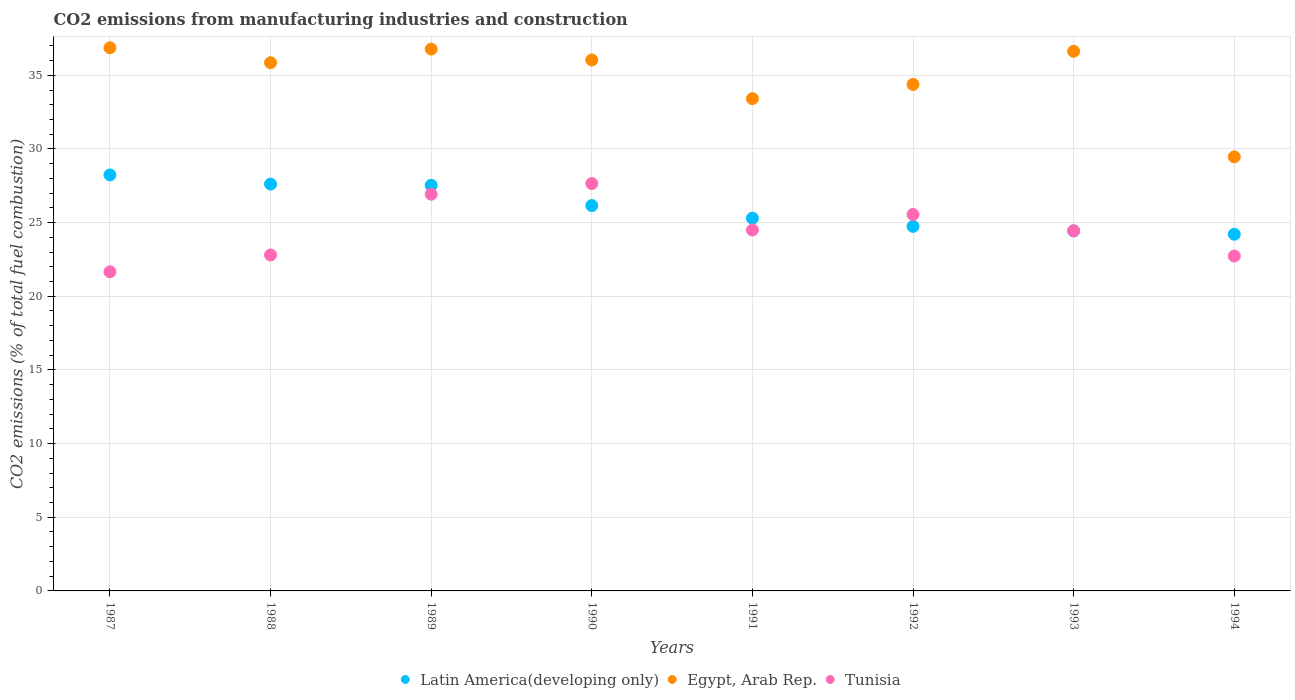How many different coloured dotlines are there?
Keep it short and to the point. 3. What is the amount of CO2 emitted in Tunisia in 1989?
Offer a terse response. 26.93. Across all years, what is the maximum amount of CO2 emitted in Tunisia?
Offer a terse response. 27.65. Across all years, what is the minimum amount of CO2 emitted in Latin America(developing only)?
Keep it short and to the point. 24.21. In which year was the amount of CO2 emitted in Egypt, Arab Rep. maximum?
Offer a terse response. 1987. What is the total amount of CO2 emitted in Tunisia in the graph?
Your answer should be very brief. 196.26. What is the difference between the amount of CO2 emitted in Egypt, Arab Rep. in 1993 and that in 1994?
Offer a very short reply. 7.17. What is the difference between the amount of CO2 emitted in Tunisia in 1991 and the amount of CO2 emitted in Egypt, Arab Rep. in 1990?
Your answer should be compact. -11.54. What is the average amount of CO2 emitted in Egypt, Arab Rep. per year?
Provide a succinct answer. 34.93. In the year 1991, what is the difference between the amount of CO2 emitted in Latin America(developing only) and amount of CO2 emitted in Tunisia?
Make the answer very short. 0.8. What is the ratio of the amount of CO2 emitted in Egypt, Arab Rep. in 1987 to that in 1990?
Give a very brief answer. 1.02. Is the difference between the amount of CO2 emitted in Latin America(developing only) in 1988 and 1993 greater than the difference between the amount of CO2 emitted in Tunisia in 1988 and 1993?
Keep it short and to the point. Yes. What is the difference between the highest and the second highest amount of CO2 emitted in Egypt, Arab Rep.?
Make the answer very short. 0.09. What is the difference between the highest and the lowest amount of CO2 emitted in Egypt, Arab Rep.?
Make the answer very short. 7.4. In how many years, is the amount of CO2 emitted in Tunisia greater than the average amount of CO2 emitted in Tunisia taken over all years?
Offer a very short reply. 3. Is the sum of the amount of CO2 emitted in Egypt, Arab Rep. in 1989 and 1992 greater than the maximum amount of CO2 emitted in Tunisia across all years?
Offer a very short reply. Yes. Does the amount of CO2 emitted in Latin America(developing only) monotonically increase over the years?
Offer a terse response. No. Is the amount of CO2 emitted in Latin America(developing only) strictly less than the amount of CO2 emitted in Egypt, Arab Rep. over the years?
Your answer should be compact. Yes. How are the legend labels stacked?
Offer a terse response. Horizontal. What is the title of the graph?
Give a very brief answer. CO2 emissions from manufacturing industries and construction. Does "Uzbekistan" appear as one of the legend labels in the graph?
Make the answer very short. No. What is the label or title of the X-axis?
Give a very brief answer. Years. What is the label or title of the Y-axis?
Your answer should be compact. CO2 emissions (% of total fuel combustion). What is the CO2 emissions (% of total fuel combustion) in Latin America(developing only) in 1987?
Offer a very short reply. 28.24. What is the CO2 emissions (% of total fuel combustion) in Egypt, Arab Rep. in 1987?
Your answer should be very brief. 36.87. What is the CO2 emissions (% of total fuel combustion) in Tunisia in 1987?
Provide a short and direct response. 21.66. What is the CO2 emissions (% of total fuel combustion) in Latin America(developing only) in 1988?
Your answer should be very brief. 27.61. What is the CO2 emissions (% of total fuel combustion) of Egypt, Arab Rep. in 1988?
Provide a succinct answer. 35.85. What is the CO2 emissions (% of total fuel combustion) of Tunisia in 1988?
Offer a terse response. 22.8. What is the CO2 emissions (% of total fuel combustion) in Latin America(developing only) in 1989?
Provide a short and direct response. 27.53. What is the CO2 emissions (% of total fuel combustion) in Egypt, Arab Rep. in 1989?
Your answer should be very brief. 36.78. What is the CO2 emissions (% of total fuel combustion) of Tunisia in 1989?
Provide a succinct answer. 26.93. What is the CO2 emissions (% of total fuel combustion) of Latin America(developing only) in 1990?
Ensure brevity in your answer.  26.15. What is the CO2 emissions (% of total fuel combustion) of Egypt, Arab Rep. in 1990?
Your response must be concise. 36.04. What is the CO2 emissions (% of total fuel combustion) of Tunisia in 1990?
Provide a succinct answer. 27.65. What is the CO2 emissions (% of total fuel combustion) of Latin America(developing only) in 1991?
Your response must be concise. 25.3. What is the CO2 emissions (% of total fuel combustion) of Egypt, Arab Rep. in 1991?
Offer a terse response. 33.41. What is the CO2 emissions (% of total fuel combustion) of Tunisia in 1991?
Offer a very short reply. 24.5. What is the CO2 emissions (% of total fuel combustion) of Latin America(developing only) in 1992?
Offer a very short reply. 24.74. What is the CO2 emissions (% of total fuel combustion) of Egypt, Arab Rep. in 1992?
Give a very brief answer. 34.38. What is the CO2 emissions (% of total fuel combustion) of Tunisia in 1992?
Give a very brief answer. 25.55. What is the CO2 emissions (% of total fuel combustion) in Latin America(developing only) in 1993?
Your response must be concise. 24.44. What is the CO2 emissions (% of total fuel combustion) of Egypt, Arab Rep. in 1993?
Your response must be concise. 36.63. What is the CO2 emissions (% of total fuel combustion) of Tunisia in 1993?
Your answer should be very brief. 24.44. What is the CO2 emissions (% of total fuel combustion) in Latin America(developing only) in 1994?
Your answer should be very brief. 24.21. What is the CO2 emissions (% of total fuel combustion) of Egypt, Arab Rep. in 1994?
Provide a succinct answer. 29.46. What is the CO2 emissions (% of total fuel combustion) of Tunisia in 1994?
Ensure brevity in your answer.  22.73. Across all years, what is the maximum CO2 emissions (% of total fuel combustion) of Latin America(developing only)?
Your response must be concise. 28.24. Across all years, what is the maximum CO2 emissions (% of total fuel combustion) in Egypt, Arab Rep.?
Ensure brevity in your answer.  36.87. Across all years, what is the maximum CO2 emissions (% of total fuel combustion) of Tunisia?
Your answer should be compact. 27.65. Across all years, what is the minimum CO2 emissions (% of total fuel combustion) of Latin America(developing only)?
Your answer should be compact. 24.21. Across all years, what is the minimum CO2 emissions (% of total fuel combustion) in Egypt, Arab Rep.?
Your answer should be very brief. 29.46. Across all years, what is the minimum CO2 emissions (% of total fuel combustion) of Tunisia?
Your response must be concise. 21.66. What is the total CO2 emissions (% of total fuel combustion) of Latin America(developing only) in the graph?
Your answer should be compact. 208.22. What is the total CO2 emissions (% of total fuel combustion) of Egypt, Arab Rep. in the graph?
Offer a very short reply. 279.41. What is the total CO2 emissions (% of total fuel combustion) in Tunisia in the graph?
Your answer should be compact. 196.26. What is the difference between the CO2 emissions (% of total fuel combustion) of Latin America(developing only) in 1987 and that in 1988?
Keep it short and to the point. 0.62. What is the difference between the CO2 emissions (% of total fuel combustion) in Tunisia in 1987 and that in 1988?
Your answer should be very brief. -1.14. What is the difference between the CO2 emissions (% of total fuel combustion) of Latin America(developing only) in 1987 and that in 1989?
Your answer should be compact. 0.71. What is the difference between the CO2 emissions (% of total fuel combustion) in Egypt, Arab Rep. in 1987 and that in 1989?
Offer a very short reply. 0.09. What is the difference between the CO2 emissions (% of total fuel combustion) in Tunisia in 1987 and that in 1989?
Make the answer very short. -5.27. What is the difference between the CO2 emissions (% of total fuel combustion) of Latin America(developing only) in 1987 and that in 1990?
Keep it short and to the point. 2.08. What is the difference between the CO2 emissions (% of total fuel combustion) of Egypt, Arab Rep. in 1987 and that in 1990?
Offer a terse response. 0.83. What is the difference between the CO2 emissions (% of total fuel combustion) in Tunisia in 1987 and that in 1990?
Provide a short and direct response. -5.99. What is the difference between the CO2 emissions (% of total fuel combustion) in Latin America(developing only) in 1987 and that in 1991?
Your answer should be compact. 2.94. What is the difference between the CO2 emissions (% of total fuel combustion) of Egypt, Arab Rep. in 1987 and that in 1991?
Keep it short and to the point. 3.45. What is the difference between the CO2 emissions (% of total fuel combustion) of Tunisia in 1987 and that in 1991?
Make the answer very short. -2.84. What is the difference between the CO2 emissions (% of total fuel combustion) in Latin America(developing only) in 1987 and that in 1992?
Make the answer very short. 3.49. What is the difference between the CO2 emissions (% of total fuel combustion) in Egypt, Arab Rep. in 1987 and that in 1992?
Give a very brief answer. 2.49. What is the difference between the CO2 emissions (% of total fuel combustion) of Tunisia in 1987 and that in 1992?
Keep it short and to the point. -3.89. What is the difference between the CO2 emissions (% of total fuel combustion) of Latin America(developing only) in 1987 and that in 1993?
Your response must be concise. 3.8. What is the difference between the CO2 emissions (% of total fuel combustion) in Egypt, Arab Rep. in 1987 and that in 1993?
Your response must be concise. 0.24. What is the difference between the CO2 emissions (% of total fuel combustion) in Tunisia in 1987 and that in 1993?
Your answer should be compact. -2.78. What is the difference between the CO2 emissions (% of total fuel combustion) of Latin America(developing only) in 1987 and that in 1994?
Offer a very short reply. 4.03. What is the difference between the CO2 emissions (% of total fuel combustion) of Egypt, Arab Rep. in 1987 and that in 1994?
Offer a very short reply. 7.4. What is the difference between the CO2 emissions (% of total fuel combustion) of Tunisia in 1987 and that in 1994?
Give a very brief answer. -1.07. What is the difference between the CO2 emissions (% of total fuel combustion) in Latin America(developing only) in 1988 and that in 1989?
Offer a very short reply. 0.09. What is the difference between the CO2 emissions (% of total fuel combustion) of Egypt, Arab Rep. in 1988 and that in 1989?
Your answer should be compact. -0.93. What is the difference between the CO2 emissions (% of total fuel combustion) of Tunisia in 1988 and that in 1989?
Give a very brief answer. -4.12. What is the difference between the CO2 emissions (% of total fuel combustion) in Latin America(developing only) in 1988 and that in 1990?
Make the answer very short. 1.46. What is the difference between the CO2 emissions (% of total fuel combustion) of Egypt, Arab Rep. in 1988 and that in 1990?
Your response must be concise. -0.19. What is the difference between the CO2 emissions (% of total fuel combustion) of Tunisia in 1988 and that in 1990?
Provide a succinct answer. -4.85. What is the difference between the CO2 emissions (% of total fuel combustion) in Latin America(developing only) in 1988 and that in 1991?
Offer a very short reply. 2.32. What is the difference between the CO2 emissions (% of total fuel combustion) of Egypt, Arab Rep. in 1988 and that in 1991?
Your answer should be very brief. 2.44. What is the difference between the CO2 emissions (% of total fuel combustion) in Tunisia in 1988 and that in 1991?
Your answer should be compact. -1.69. What is the difference between the CO2 emissions (% of total fuel combustion) of Latin America(developing only) in 1988 and that in 1992?
Provide a short and direct response. 2.87. What is the difference between the CO2 emissions (% of total fuel combustion) of Egypt, Arab Rep. in 1988 and that in 1992?
Keep it short and to the point. 1.47. What is the difference between the CO2 emissions (% of total fuel combustion) in Tunisia in 1988 and that in 1992?
Provide a succinct answer. -2.75. What is the difference between the CO2 emissions (% of total fuel combustion) of Latin America(developing only) in 1988 and that in 1993?
Offer a terse response. 3.18. What is the difference between the CO2 emissions (% of total fuel combustion) in Egypt, Arab Rep. in 1988 and that in 1993?
Make the answer very short. -0.78. What is the difference between the CO2 emissions (% of total fuel combustion) of Tunisia in 1988 and that in 1993?
Offer a terse response. -1.64. What is the difference between the CO2 emissions (% of total fuel combustion) of Latin America(developing only) in 1988 and that in 1994?
Provide a short and direct response. 3.4. What is the difference between the CO2 emissions (% of total fuel combustion) in Egypt, Arab Rep. in 1988 and that in 1994?
Your answer should be very brief. 6.39. What is the difference between the CO2 emissions (% of total fuel combustion) of Tunisia in 1988 and that in 1994?
Give a very brief answer. 0.07. What is the difference between the CO2 emissions (% of total fuel combustion) of Latin America(developing only) in 1989 and that in 1990?
Provide a short and direct response. 1.37. What is the difference between the CO2 emissions (% of total fuel combustion) in Egypt, Arab Rep. in 1989 and that in 1990?
Your response must be concise. 0.74. What is the difference between the CO2 emissions (% of total fuel combustion) of Tunisia in 1989 and that in 1990?
Your response must be concise. -0.72. What is the difference between the CO2 emissions (% of total fuel combustion) of Latin America(developing only) in 1989 and that in 1991?
Give a very brief answer. 2.23. What is the difference between the CO2 emissions (% of total fuel combustion) in Egypt, Arab Rep. in 1989 and that in 1991?
Offer a very short reply. 3.36. What is the difference between the CO2 emissions (% of total fuel combustion) in Tunisia in 1989 and that in 1991?
Provide a short and direct response. 2.43. What is the difference between the CO2 emissions (% of total fuel combustion) of Latin America(developing only) in 1989 and that in 1992?
Your answer should be compact. 2.78. What is the difference between the CO2 emissions (% of total fuel combustion) in Egypt, Arab Rep. in 1989 and that in 1992?
Keep it short and to the point. 2.4. What is the difference between the CO2 emissions (% of total fuel combustion) in Tunisia in 1989 and that in 1992?
Offer a terse response. 1.38. What is the difference between the CO2 emissions (% of total fuel combustion) of Latin America(developing only) in 1989 and that in 1993?
Your answer should be compact. 3.09. What is the difference between the CO2 emissions (% of total fuel combustion) in Egypt, Arab Rep. in 1989 and that in 1993?
Offer a very short reply. 0.15. What is the difference between the CO2 emissions (% of total fuel combustion) in Tunisia in 1989 and that in 1993?
Offer a terse response. 2.48. What is the difference between the CO2 emissions (% of total fuel combustion) in Latin America(developing only) in 1989 and that in 1994?
Your answer should be compact. 3.32. What is the difference between the CO2 emissions (% of total fuel combustion) of Egypt, Arab Rep. in 1989 and that in 1994?
Ensure brevity in your answer.  7.32. What is the difference between the CO2 emissions (% of total fuel combustion) in Tunisia in 1989 and that in 1994?
Provide a succinct answer. 4.2. What is the difference between the CO2 emissions (% of total fuel combustion) of Latin America(developing only) in 1990 and that in 1991?
Keep it short and to the point. 0.86. What is the difference between the CO2 emissions (% of total fuel combustion) of Egypt, Arab Rep. in 1990 and that in 1991?
Your answer should be compact. 2.62. What is the difference between the CO2 emissions (% of total fuel combustion) of Tunisia in 1990 and that in 1991?
Give a very brief answer. 3.15. What is the difference between the CO2 emissions (% of total fuel combustion) of Latin America(developing only) in 1990 and that in 1992?
Ensure brevity in your answer.  1.41. What is the difference between the CO2 emissions (% of total fuel combustion) in Egypt, Arab Rep. in 1990 and that in 1992?
Provide a succinct answer. 1.66. What is the difference between the CO2 emissions (% of total fuel combustion) in Tunisia in 1990 and that in 1992?
Keep it short and to the point. 2.1. What is the difference between the CO2 emissions (% of total fuel combustion) of Latin America(developing only) in 1990 and that in 1993?
Your answer should be compact. 1.72. What is the difference between the CO2 emissions (% of total fuel combustion) of Egypt, Arab Rep. in 1990 and that in 1993?
Keep it short and to the point. -0.59. What is the difference between the CO2 emissions (% of total fuel combustion) in Tunisia in 1990 and that in 1993?
Your answer should be compact. 3.2. What is the difference between the CO2 emissions (% of total fuel combustion) in Latin America(developing only) in 1990 and that in 1994?
Provide a short and direct response. 1.94. What is the difference between the CO2 emissions (% of total fuel combustion) in Egypt, Arab Rep. in 1990 and that in 1994?
Ensure brevity in your answer.  6.58. What is the difference between the CO2 emissions (% of total fuel combustion) of Tunisia in 1990 and that in 1994?
Make the answer very short. 4.92. What is the difference between the CO2 emissions (% of total fuel combustion) in Latin America(developing only) in 1991 and that in 1992?
Give a very brief answer. 0.55. What is the difference between the CO2 emissions (% of total fuel combustion) in Egypt, Arab Rep. in 1991 and that in 1992?
Give a very brief answer. -0.96. What is the difference between the CO2 emissions (% of total fuel combustion) of Tunisia in 1991 and that in 1992?
Offer a very short reply. -1.05. What is the difference between the CO2 emissions (% of total fuel combustion) of Latin America(developing only) in 1991 and that in 1993?
Give a very brief answer. 0.86. What is the difference between the CO2 emissions (% of total fuel combustion) in Egypt, Arab Rep. in 1991 and that in 1993?
Ensure brevity in your answer.  -3.21. What is the difference between the CO2 emissions (% of total fuel combustion) of Tunisia in 1991 and that in 1993?
Ensure brevity in your answer.  0.05. What is the difference between the CO2 emissions (% of total fuel combustion) in Latin America(developing only) in 1991 and that in 1994?
Ensure brevity in your answer.  1.09. What is the difference between the CO2 emissions (% of total fuel combustion) in Egypt, Arab Rep. in 1991 and that in 1994?
Provide a succinct answer. 3.95. What is the difference between the CO2 emissions (% of total fuel combustion) in Tunisia in 1991 and that in 1994?
Ensure brevity in your answer.  1.77. What is the difference between the CO2 emissions (% of total fuel combustion) of Latin America(developing only) in 1992 and that in 1993?
Make the answer very short. 0.31. What is the difference between the CO2 emissions (% of total fuel combustion) in Egypt, Arab Rep. in 1992 and that in 1993?
Provide a short and direct response. -2.25. What is the difference between the CO2 emissions (% of total fuel combustion) of Tunisia in 1992 and that in 1993?
Ensure brevity in your answer.  1.11. What is the difference between the CO2 emissions (% of total fuel combustion) in Latin America(developing only) in 1992 and that in 1994?
Make the answer very short. 0.53. What is the difference between the CO2 emissions (% of total fuel combustion) of Egypt, Arab Rep. in 1992 and that in 1994?
Ensure brevity in your answer.  4.92. What is the difference between the CO2 emissions (% of total fuel combustion) in Tunisia in 1992 and that in 1994?
Your answer should be compact. 2.82. What is the difference between the CO2 emissions (% of total fuel combustion) in Latin America(developing only) in 1993 and that in 1994?
Offer a terse response. 0.23. What is the difference between the CO2 emissions (% of total fuel combustion) in Egypt, Arab Rep. in 1993 and that in 1994?
Offer a very short reply. 7.17. What is the difference between the CO2 emissions (% of total fuel combustion) in Tunisia in 1993 and that in 1994?
Provide a succinct answer. 1.71. What is the difference between the CO2 emissions (% of total fuel combustion) of Latin America(developing only) in 1987 and the CO2 emissions (% of total fuel combustion) of Egypt, Arab Rep. in 1988?
Ensure brevity in your answer.  -7.62. What is the difference between the CO2 emissions (% of total fuel combustion) in Latin America(developing only) in 1987 and the CO2 emissions (% of total fuel combustion) in Tunisia in 1988?
Your response must be concise. 5.43. What is the difference between the CO2 emissions (% of total fuel combustion) of Egypt, Arab Rep. in 1987 and the CO2 emissions (% of total fuel combustion) of Tunisia in 1988?
Keep it short and to the point. 14.06. What is the difference between the CO2 emissions (% of total fuel combustion) in Latin America(developing only) in 1987 and the CO2 emissions (% of total fuel combustion) in Egypt, Arab Rep. in 1989?
Provide a succinct answer. -8.54. What is the difference between the CO2 emissions (% of total fuel combustion) of Latin America(developing only) in 1987 and the CO2 emissions (% of total fuel combustion) of Tunisia in 1989?
Give a very brief answer. 1.31. What is the difference between the CO2 emissions (% of total fuel combustion) of Egypt, Arab Rep. in 1987 and the CO2 emissions (% of total fuel combustion) of Tunisia in 1989?
Provide a short and direct response. 9.94. What is the difference between the CO2 emissions (% of total fuel combustion) in Latin America(developing only) in 1987 and the CO2 emissions (% of total fuel combustion) in Egypt, Arab Rep. in 1990?
Offer a terse response. -7.8. What is the difference between the CO2 emissions (% of total fuel combustion) in Latin America(developing only) in 1987 and the CO2 emissions (% of total fuel combustion) in Tunisia in 1990?
Offer a very short reply. 0.59. What is the difference between the CO2 emissions (% of total fuel combustion) of Egypt, Arab Rep. in 1987 and the CO2 emissions (% of total fuel combustion) of Tunisia in 1990?
Give a very brief answer. 9.22. What is the difference between the CO2 emissions (% of total fuel combustion) of Latin America(developing only) in 1987 and the CO2 emissions (% of total fuel combustion) of Egypt, Arab Rep. in 1991?
Ensure brevity in your answer.  -5.18. What is the difference between the CO2 emissions (% of total fuel combustion) in Latin America(developing only) in 1987 and the CO2 emissions (% of total fuel combustion) in Tunisia in 1991?
Provide a short and direct response. 3.74. What is the difference between the CO2 emissions (% of total fuel combustion) in Egypt, Arab Rep. in 1987 and the CO2 emissions (% of total fuel combustion) in Tunisia in 1991?
Keep it short and to the point. 12.37. What is the difference between the CO2 emissions (% of total fuel combustion) in Latin America(developing only) in 1987 and the CO2 emissions (% of total fuel combustion) in Egypt, Arab Rep. in 1992?
Offer a very short reply. -6.14. What is the difference between the CO2 emissions (% of total fuel combustion) of Latin America(developing only) in 1987 and the CO2 emissions (% of total fuel combustion) of Tunisia in 1992?
Offer a terse response. 2.68. What is the difference between the CO2 emissions (% of total fuel combustion) in Egypt, Arab Rep. in 1987 and the CO2 emissions (% of total fuel combustion) in Tunisia in 1992?
Your answer should be compact. 11.31. What is the difference between the CO2 emissions (% of total fuel combustion) of Latin America(developing only) in 1987 and the CO2 emissions (% of total fuel combustion) of Egypt, Arab Rep. in 1993?
Provide a short and direct response. -8.39. What is the difference between the CO2 emissions (% of total fuel combustion) in Latin America(developing only) in 1987 and the CO2 emissions (% of total fuel combustion) in Tunisia in 1993?
Offer a terse response. 3.79. What is the difference between the CO2 emissions (% of total fuel combustion) in Egypt, Arab Rep. in 1987 and the CO2 emissions (% of total fuel combustion) in Tunisia in 1993?
Ensure brevity in your answer.  12.42. What is the difference between the CO2 emissions (% of total fuel combustion) in Latin America(developing only) in 1987 and the CO2 emissions (% of total fuel combustion) in Egypt, Arab Rep. in 1994?
Provide a succinct answer. -1.23. What is the difference between the CO2 emissions (% of total fuel combustion) of Latin America(developing only) in 1987 and the CO2 emissions (% of total fuel combustion) of Tunisia in 1994?
Your answer should be compact. 5.51. What is the difference between the CO2 emissions (% of total fuel combustion) in Egypt, Arab Rep. in 1987 and the CO2 emissions (% of total fuel combustion) in Tunisia in 1994?
Give a very brief answer. 14.14. What is the difference between the CO2 emissions (% of total fuel combustion) in Latin America(developing only) in 1988 and the CO2 emissions (% of total fuel combustion) in Egypt, Arab Rep. in 1989?
Offer a very short reply. -9.16. What is the difference between the CO2 emissions (% of total fuel combustion) in Latin America(developing only) in 1988 and the CO2 emissions (% of total fuel combustion) in Tunisia in 1989?
Provide a succinct answer. 0.69. What is the difference between the CO2 emissions (% of total fuel combustion) of Egypt, Arab Rep. in 1988 and the CO2 emissions (% of total fuel combustion) of Tunisia in 1989?
Your response must be concise. 8.93. What is the difference between the CO2 emissions (% of total fuel combustion) of Latin America(developing only) in 1988 and the CO2 emissions (% of total fuel combustion) of Egypt, Arab Rep. in 1990?
Your answer should be very brief. -8.42. What is the difference between the CO2 emissions (% of total fuel combustion) in Latin America(developing only) in 1988 and the CO2 emissions (% of total fuel combustion) in Tunisia in 1990?
Offer a terse response. -0.04. What is the difference between the CO2 emissions (% of total fuel combustion) of Egypt, Arab Rep. in 1988 and the CO2 emissions (% of total fuel combustion) of Tunisia in 1990?
Offer a terse response. 8.2. What is the difference between the CO2 emissions (% of total fuel combustion) of Latin America(developing only) in 1988 and the CO2 emissions (% of total fuel combustion) of Egypt, Arab Rep. in 1991?
Your response must be concise. -5.8. What is the difference between the CO2 emissions (% of total fuel combustion) of Latin America(developing only) in 1988 and the CO2 emissions (% of total fuel combustion) of Tunisia in 1991?
Offer a terse response. 3.12. What is the difference between the CO2 emissions (% of total fuel combustion) in Egypt, Arab Rep. in 1988 and the CO2 emissions (% of total fuel combustion) in Tunisia in 1991?
Give a very brief answer. 11.36. What is the difference between the CO2 emissions (% of total fuel combustion) in Latin America(developing only) in 1988 and the CO2 emissions (% of total fuel combustion) in Egypt, Arab Rep. in 1992?
Give a very brief answer. -6.76. What is the difference between the CO2 emissions (% of total fuel combustion) in Latin America(developing only) in 1988 and the CO2 emissions (% of total fuel combustion) in Tunisia in 1992?
Your answer should be very brief. 2.06. What is the difference between the CO2 emissions (% of total fuel combustion) of Egypt, Arab Rep. in 1988 and the CO2 emissions (% of total fuel combustion) of Tunisia in 1992?
Your answer should be very brief. 10.3. What is the difference between the CO2 emissions (% of total fuel combustion) in Latin America(developing only) in 1988 and the CO2 emissions (% of total fuel combustion) in Egypt, Arab Rep. in 1993?
Make the answer very short. -9.01. What is the difference between the CO2 emissions (% of total fuel combustion) of Latin America(developing only) in 1988 and the CO2 emissions (% of total fuel combustion) of Tunisia in 1993?
Make the answer very short. 3.17. What is the difference between the CO2 emissions (% of total fuel combustion) in Egypt, Arab Rep. in 1988 and the CO2 emissions (% of total fuel combustion) in Tunisia in 1993?
Ensure brevity in your answer.  11.41. What is the difference between the CO2 emissions (% of total fuel combustion) of Latin America(developing only) in 1988 and the CO2 emissions (% of total fuel combustion) of Egypt, Arab Rep. in 1994?
Make the answer very short. -1.85. What is the difference between the CO2 emissions (% of total fuel combustion) in Latin America(developing only) in 1988 and the CO2 emissions (% of total fuel combustion) in Tunisia in 1994?
Your answer should be compact. 4.88. What is the difference between the CO2 emissions (% of total fuel combustion) of Egypt, Arab Rep. in 1988 and the CO2 emissions (% of total fuel combustion) of Tunisia in 1994?
Your answer should be compact. 13.12. What is the difference between the CO2 emissions (% of total fuel combustion) in Latin America(developing only) in 1989 and the CO2 emissions (% of total fuel combustion) in Egypt, Arab Rep. in 1990?
Your answer should be very brief. -8.51. What is the difference between the CO2 emissions (% of total fuel combustion) of Latin America(developing only) in 1989 and the CO2 emissions (% of total fuel combustion) of Tunisia in 1990?
Ensure brevity in your answer.  -0.12. What is the difference between the CO2 emissions (% of total fuel combustion) in Egypt, Arab Rep. in 1989 and the CO2 emissions (% of total fuel combustion) in Tunisia in 1990?
Give a very brief answer. 9.13. What is the difference between the CO2 emissions (% of total fuel combustion) in Latin America(developing only) in 1989 and the CO2 emissions (% of total fuel combustion) in Egypt, Arab Rep. in 1991?
Your answer should be compact. -5.89. What is the difference between the CO2 emissions (% of total fuel combustion) of Latin America(developing only) in 1989 and the CO2 emissions (% of total fuel combustion) of Tunisia in 1991?
Offer a very short reply. 3.03. What is the difference between the CO2 emissions (% of total fuel combustion) of Egypt, Arab Rep. in 1989 and the CO2 emissions (% of total fuel combustion) of Tunisia in 1991?
Give a very brief answer. 12.28. What is the difference between the CO2 emissions (% of total fuel combustion) of Latin America(developing only) in 1989 and the CO2 emissions (% of total fuel combustion) of Egypt, Arab Rep. in 1992?
Give a very brief answer. -6.85. What is the difference between the CO2 emissions (% of total fuel combustion) in Latin America(developing only) in 1989 and the CO2 emissions (% of total fuel combustion) in Tunisia in 1992?
Your answer should be compact. 1.98. What is the difference between the CO2 emissions (% of total fuel combustion) of Egypt, Arab Rep. in 1989 and the CO2 emissions (% of total fuel combustion) of Tunisia in 1992?
Offer a very short reply. 11.23. What is the difference between the CO2 emissions (% of total fuel combustion) in Latin America(developing only) in 1989 and the CO2 emissions (% of total fuel combustion) in Egypt, Arab Rep. in 1993?
Your answer should be compact. -9.1. What is the difference between the CO2 emissions (% of total fuel combustion) of Latin America(developing only) in 1989 and the CO2 emissions (% of total fuel combustion) of Tunisia in 1993?
Provide a short and direct response. 3.08. What is the difference between the CO2 emissions (% of total fuel combustion) in Egypt, Arab Rep. in 1989 and the CO2 emissions (% of total fuel combustion) in Tunisia in 1993?
Your answer should be very brief. 12.33. What is the difference between the CO2 emissions (% of total fuel combustion) in Latin America(developing only) in 1989 and the CO2 emissions (% of total fuel combustion) in Egypt, Arab Rep. in 1994?
Your answer should be compact. -1.93. What is the difference between the CO2 emissions (% of total fuel combustion) of Latin America(developing only) in 1989 and the CO2 emissions (% of total fuel combustion) of Tunisia in 1994?
Make the answer very short. 4.8. What is the difference between the CO2 emissions (% of total fuel combustion) of Egypt, Arab Rep. in 1989 and the CO2 emissions (% of total fuel combustion) of Tunisia in 1994?
Offer a very short reply. 14.05. What is the difference between the CO2 emissions (% of total fuel combustion) of Latin America(developing only) in 1990 and the CO2 emissions (% of total fuel combustion) of Egypt, Arab Rep. in 1991?
Make the answer very short. -7.26. What is the difference between the CO2 emissions (% of total fuel combustion) of Latin America(developing only) in 1990 and the CO2 emissions (% of total fuel combustion) of Tunisia in 1991?
Your response must be concise. 1.66. What is the difference between the CO2 emissions (% of total fuel combustion) of Egypt, Arab Rep. in 1990 and the CO2 emissions (% of total fuel combustion) of Tunisia in 1991?
Ensure brevity in your answer.  11.54. What is the difference between the CO2 emissions (% of total fuel combustion) in Latin America(developing only) in 1990 and the CO2 emissions (% of total fuel combustion) in Egypt, Arab Rep. in 1992?
Provide a short and direct response. -8.22. What is the difference between the CO2 emissions (% of total fuel combustion) in Latin America(developing only) in 1990 and the CO2 emissions (% of total fuel combustion) in Tunisia in 1992?
Offer a terse response. 0.6. What is the difference between the CO2 emissions (% of total fuel combustion) of Egypt, Arab Rep. in 1990 and the CO2 emissions (% of total fuel combustion) of Tunisia in 1992?
Your answer should be compact. 10.49. What is the difference between the CO2 emissions (% of total fuel combustion) of Latin America(developing only) in 1990 and the CO2 emissions (% of total fuel combustion) of Egypt, Arab Rep. in 1993?
Your answer should be compact. -10.47. What is the difference between the CO2 emissions (% of total fuel combustion) of Latin America(developing only) in 1990 and the CO2 emissions (% of total fuel combustion) of Tunisia in 1993?
Your answer should be very brief. 1.71. What is the difference between the CO2 emissions (% of total fuel combustion) in Egypt, Arab Rep. in 1990 and the CO2 emissions (% of total fuel combustion) in Tunisia in 1993?
Provide a succinct answer. 11.59. What is the difference between the CO2 emissions (% of total fuel combustion) in Latin America(developing only) in 1990 and the CO2 emissions (% of total fuel combustion) in Egypt, Arab Rep. in 1994?
Provide a short and direct response. -3.31. What is the difference between the CO2 emissions (% of total fuel combustion) in Latin America(developing only) in 1990 and the CO2 emissions (% of total fuel combustion) in Tunisia in 1994?
Offer a very short reply. 3.42. What is the difference between the CO2 emissions (% of total fuel combustion) of Egypt, Arab Rep. in 1990 and the CO2 emissions (% of total fuel combustion) of Tunisia in 1994?
Provide a succinct answer. 13.31. What is the difference between the CO2 emissions (% of total fuel combustion) of Latin America(developing only) in 1991 and the CO2 emissions (% of total fuel combustion) of Egypt, Arab Rep. in 1992?
Offer a very short reply. -9.08. What is the difference between the CO2 emissions (% of total fuel combustion) of Latin America(developing only) in 1991 and the CO2 emissions (% of total fuel combustion) of Tunisia in 1992?
Offer a terse response. -0.25. What is the difference between the CO2 emissions (% of total fuel combustion) in Egypt, Arab Rep. in 1991 and the CO2 emissions (% of total fuel combustion) in Tunisia in 1992?
Give a very brief answer. 7.86. What is the difference between the CO2 emissions (% of total fuel combustion) in Latin America(developing only) in 1991 and the CO2 emissions (% of total fuel combustion) in Egypt, Arab Rep. in 1993?
Keep it short and to the point. -11.33. What is the difference between the CO2 emissions (% of total fuel combustion) of Latin America(developing only) in 1991 and the CO2 emissions (% of total fuel combustion) of Tunisia in 1993?
Your response must be concise. 0.85. What is the difference between the CO2 emissions (% of total fuel combustion) of Egypt, Arab Rep. in 1991 and the CO2 emissions (% of total fuel combustion) of Tunisia in 1993?
Keep it short and to the point. 8.97. What is the difference between the CO2 emissions (% of total fuel combustion) of Latin America(developing only) in 1991 and the CO2 emissions (% of total fuel combustion) of Egypt, Arab Rep. in 1994?
Make the answer very short. -4.16. What is the difference between the CO2 emissions (% of total fuel combustion) of Latin America(developing only) in 1991 and the CO2 emissions (% of total fuel combustion) of Tunisia in 1994?
Provide a succinct answer. 2.57. What is the difference between the CO2 emissions (% of total fuel combustion) in Egypt, Arab Rep. in 1991 and the CO2 emissions (% of total fuel combustion) in Tunisia in 1994?
Your response must be concise. 10.68. What is the difference between the CO2 emissions (% of total fuel combustion) in Latin America(developing only) in 1992 and the CO2 emissions (% of total fuel combustion) in Egypt, Arab Rep. in 1993?
Offer a terse response. -11.88. What is the difference between the CO2 emissions (% of total fuel combustion) in Latin America(developing only) in 1992 and the CO2 emissions (% of total fuel combustion) in Tunisia in 1993?
Make the answer very short. 0.3. What is the difference between the CO2 emissions (% of total fuel combustion) of Egypt, Arab Rep. in 1992 and the CO2 emissions (% of total fuel combustion) of Tunisia in 1993?
Your answer should be very brief. 9.93. What is the difference between the CO2 emissions (% of total fuel combustion) in Latin America(developing only) in 1992 and the CO2 emissions (% of total fuel combustion) in Egypt, Arab Rep. in 1994?
Provide a short and direct response. -4.72. What is the difference between the CO2 emissions (% of total fuel combustion) in Latin America(developing only) in 1992 and the CO2 emissions (% of total fuel combustion) in Tunisia in 1994?
Provide a short and direct response. 2.01. What is the difference between the CO2 emissions (% of total fuel combustion) of Egypt, Arab Rep. in 1992 and the CO2 emissions (% of total fuel combustion) of Tunisia in 1994?
Give a very brief answer. 11.65. What is the difference between the CO2 emissions (% of total fuel combustion) of Latin America(developing only) in 1993 and the CO2 emissions (% of total fuel combustion) of Egypt, Arab Rep. in 1994?
Your response must be concise. -5.03. What is the difference between the CO2 emissions (% of total fuel combustion) in Latin America(developing only) in 1993 and the CO2 emissions (% of total fuel combustion) in Tunisia in 1994?
Make the answer very short. 1.71. What is the difference between the CO2 emissions (% of total fuel combustion) in Egypt, Arab Rep. in 1993 and the CO2 emissions (% of total fuel combustion) in Tunisia in 1994?
Give a very brief answer. 13.9. What is the average CO2 emissions (% of total fuel combustion) in Latin America(developing only) per year?
Offer a very short reply. 26.03. What is the average CO2 emissions (% of total fuel combustion) of Egypt, Arab Rep. per year?
Ensure brevity in your answer.  34.93. What is the average CO2 emissions (% of total fuel combustion) of Tunisia per year?
Keep it short and to the point. 24.53. In the year 1987, what is the difference between the CO2 emissions (% of total fuel combustion) in Latin America(developing only) and CO2 emissions (% of total fuel combustion) in Egypt, Arab Rep.?
Offer a terse response. -8.63. In the year 1987, what is the difference between the CO2 emissions (% of total fuel combustion) in Latin America(developing only) and CO2 emissions (% of total fuel combustion) in Tunisia?
Give a very brief answer. 6.58. In the year 1987, what is the difference between the CO2 emissions (% of total fuel combustion) in Egypt, Arab Rep. and CO2 emissions (% of total fuel combustion) in Tunisia?
Your answer should be compact. 15.21. In the year 1988, what is the difference between the CO2 emissions (% of total fuel combustion) of Latin America(developing only) and CO2 emissions (% of total fuel combustion) of Egypt, Arab Rep.?
Ensure brevity in your answer.  -8.24. In the year 1988, what is the difference between the CO2 emissions (% of total fuel combustion) of Latin America(developing only) and CO2 emissions (% of total fuel combustion) of Tunisia?
Your answer should be compact. 4.81. In the year 1988, what is the difference between the CO2 emissions (% of total fuel combustion) in Egypt, Arab Rep. and CO2 emissions (% of total fuel combustion) in Tunisia?
Provide a succinct answer. 13.05. In the year 1989, what is the difference between the CO2 emissions (% of total fuel combustion) in Latin America(developing only) and CO2 emissions (% of total fuel combustion) in Egypt, Arab Rep.?
Your answer should be compact. -9.25. In the year 1989, what is the difference between the CO2 emissions (% of total fuel combustion) of Latin America(developing only) and CO2 emissions (% of total fuel combustion) of Tunisia?
Your answer should be very brief. 0.6. In the year 1989, what is the difference between the CO2 emissions (% of total fuel combustion) of Egypt, Arab Rep. and CO2 emissions (% of total fuel combustion) of Tunisia?
Offer a very short reply. 9.85. In the year 1990, what is the difference between the CO2 emissions (% of total fuel combustion) of Latin America(developing only) and CO2 emissions (% of total fuel combustion) of Egypt, Arab Rep.?
Ensure brevity in your answer.  -9.88. In the year 1990, what is the difference between the CO2 emissions (% of total fuel combustion) of Latin America(developing only) and CO2 emissions (% of total fuel combustion) of Tunisia?
Provide a short and direct response. -1.49. In the year 1990, what is the difference between the CO2 emissions (% of total fuel combustion) in Egypt, Arab Rep. and CO2 emissions (% of total fuel combustion) in Tunisia?
Ensure brevity in your answer.  8.39. In the year 1991, what is the difference between the CO2 emissions (% of total fuel combustion) of Latin America(developing only) and CO2 emissions (% of total fuel combustion) of Egypt, Arab Rep.?
Keep it short and to the point. -8.12. In the year 1991, what is the difference between the CO2 emissions (% of total fuel combustion) of Latin America(developing only) and CO2 emissions (% of total fuel combustion) of Tunisia?
Give a very brief answer. 0.8. In the year 1991, what is the difference between the CO2 emissions (% of total fuel combustion) in Egypt, Arab Rep. and CO2 emissions (% of total fuel combustion) in Tunisia?
Offer a very short reply. 8.92. In the year 1992, what is the difference between the CO2 emissions (% of total fuel combustion) of Latin America(developing only) and CO2 emissions (% of total fuel combustion) of Egypt, Arab Rep.?
Offer a terse response. -9.63. In the year 1992, what is the difference between the CO2 emissions (% of total fuel combustion) of Latin America(developing only) and CO2 emissions (% of total fuel combustion) of Tunisia?
Offer a terse response. -0.81. In the year 1992, what is the difference between the CO2 emissions (% of total fuel combustion) in Egypt, Arab Rep. and CO2 emissions (% of total fuel combustion) in Tunisia?
Your answer should be very brief. 8.83. In the year 1993, what is the difference between the CO2 emissions (% of total fuel combustion) of Latin America(developing only) and CO2 emissions (% of total fuel combustion) of Egypt, Arab Rep.?
Keep it short and to the point. -12.19. In the year 1993, what is the difference between the CO2 emissions (% of total fuel combustion) in Latin America(developing only) and CO2 emissions (% of total fuel combustion) in Tunisia?
Your response must be concise. -0.01. In the year 1993, what is the difference between the CO2 emissions (% of total fuel combustion) of Egypt, Arab Rep. and CO2 emissions (% of total fuel combustion) of Tunisia?
Offer a terse response. 12.18. In the year 1994, what is the difference between the CO2 emissions (% of total fuel combustion) of Latin America(developing only) and CO2 emissions (% of total fuel combustion) of Egypt, Arab Rep.?
Ensure brevity in your answer.  -5.25. In the year 1994, what is the difference between the CO2 emissions (% of total fuel combustion) in Latin America(developing only) and CO2 emissions (% of total fuel combustion) in Tunisia?
Give a very brief answer. 1.48. In the year 1994, what is the difference between the CO2 emissions (% of total fuel combustion) of Egypt, Arab Rep. and CO2 emissions (% of total fuel combustion) of Tunisia?
Offer a terse response. 6.73. What is the ratio of the CO2 emissions (% of total fuel combustion) in Latin America(developing only) in 1987 to that in 1988?
Give a very brief answer. 1.02. What is the ratio of the CO2 emissions (% of total fuel combustion) in Egypt, Arab Rep. in 1987 to that in 1988?
Give a very brief answer. 1.03. What is the ratio of the CO2 emissions (% of total fuel combustion) in Tunisia in 1987 to that in 1988?
Your response must be concise. 0.95. What is the ratio of the CO2 emissions (% of total fuel combustion) in Latin America(developing only) in 1987 to that in 1989?
Your answer should be very brief. 1.03. What is the ratio of the CO2 emissions (% of total fuel combustion) in Egypt, Arab Rep. in 1987 to that in 1989?
Your response must be concise. 1. What is the ratio of the CO2 emissions (% of total fuel combustion) in Tunisia in 1987 to that in 1989?
Provide a succinct answer. 0.8. What is the ratio of the CO2 emissions (% of total fuel combustion) of Latin America(developing only) in 1987 to that in 1990?
Your answer should be very brief. 1.08. What is the ratio of the CO2 emissions (% of total fuel combustion) in Tunisia in 1987 to that in 1990?
Ensure brevity in your answer.  0.78. What is the ratio of the CO2 emissions (% of total fuel combustion) of Latin America(developing only) in 1987 to that in 1991?
Ensure brevity in your answer.  1.12. What is the ratio of the CO2 emissions (% of total fuel combustion) of Egypt, Arab Rep. in 1987 to that in 1991?
Your answer should be very brief. 1.1. What is the ratio of the CO2 emissions (% of total fuel combustion) of Tunisia in 1987 to that in 1991?
Ensure brevity in your answer.  0.88. What is the ratio of the CO2 emissions (% of total fuel combustion) of Latin America(developing only) in 1987 to that in 1992?
Keep it short and to the point. 1.14. What is the ratio of the CO2 emissions (% of total fuel combustion) in Egypt, Arab Rep. in 1987 to that in 1992?
Your answer should be very brief. 1.07. What is the ratio of the CO2 emissions (% of total fuel combustion) in Tunisia in 1987 to that in 1992?
Your answer should be very brief. 0.85. What is the ratio of the CO2 emissions (% of total fuel combustion) in Latin America(developing only) in 1987 to that in 1993?
Provide a short and direct response. 1.16. What is the ratio of the CO2 emissions (% of total fuel combustion) of Tunisia in 1987 to that in 1993?
Make the answer very short. 0.89. What is the ratio of the CO2 emissions (% of total fuel combustion) of Latin America(developing only) in 1987 to that in 1994?
Your response must be concise. 1.17. What is the ratio of the CO2 emissions (% of total fuel combustion) in Egypt, Arab Rep. in 1987 to that in 1994?
Your response must be concise. 1.25. What is the ratio of the CO2 emissions (% of total fuel combustion) of Tunisia in 1987 to that in 1994?
Your answer should be compact. 0.95. What is the ratio of the CO2 emissions (% of total fuel combustion) in Latin America(developing only) in 1988 to that in 1989?
Provide a succinct answer. 1. What is the ratio of the CO2 emissions (% of total fuel combustion) of Egypt, Arab Rep. in 1988 to that in 1989?
Provide a succinct answer. 0.97. What is the ratio of the CO2 emissions (% of total fuel combustion) in Tunisia in 1988 to that in 1989?
Make the answer very short. 0.85. What is the ratio of the CO2 emissions (% of total fuel combustion) in Latin America(developing only) in 1988 to that in 1990?
Make the answer very short. 1.06. What is the ratio of the CO2 emissions (% of total fuel combustion) of Tunisia in 1988 to that in 1990?
Your answer should be very brief. 0.82. What is the ratio of the CO2 emissions (% of total fuel combustion) in Latin America(developing only) in 1988 to that in 1991?
Provide a succinct answer. 1.09. What is the ratio of the CO2 emissions (% of total fuel combustion) of Egypt, Arab Rep. in 1988 to that in 1991?
Offer a terse response. 1.07. What is the ratio of the CO2 emissions (% of total fuel combustion) of Tunisia in 1988 to that in 1991?
Provide a succinct answer. 0.93. What is the ratio of the CO2 emissions (% of total fuel combustion) in Latin America(developing only) in 1988 to that in 1992?
Your answer should be very brief. 1.12. What is the ratio of the CO2 emissions (% of total fuel combustion) in Egypt, Arab Rep. in 1988 to that in 1992?
Make the answer very short. 1.04. What is the ratio of the CO2 emissions (% of total fuel combustion) of Tunisia in 1988 to that in 1992?
Offer a very short reply. 0.89. What is the ratio of the CO2 emissions (% of total fuel combustion) of Latin America(developing only) in 1988 to that in 1993?
Your answer should be very brief. 1.13. What is the ratio of the CO2 emissions (% of total fuel combustion) of Egypt, Arab Rep. in 1988 to that in 1993?
Provide a short and direct response. 0.98. What is the ratio of the CO2 emissions (% of total fuel combustion) in Tunisia in 1988 to that in 1993?
Offer a very short reply. 0.93. What is the ratio of the CO2 emissions (% of total fuel combustion) of Latin America(developing only) in 1988 to that in 1994?
Make the answer very short. 1.14. What is the ratio of the CO2 emissions (% of total fuel combustion) of Egypt, Arab Rep. in 1988 to that in 1994?
Keep it short and to the point. 1.22. What is the ratio of the CO2 emissions (% of total fuel combustion) in Latin America(developing only) in 1989 to that in 1990?
Make the answer very short. 1.05. What is the ratio of the CO2 emissions (% of total fuel combustion) of Egypt, Arab Rep. in 1989 to that in 1990?
Offer a very short reply. 1.02. What is the ratio of the CO2 emissions (% of total fuel combustion) in Tunisia in 1989 to that in 1990?
Your answer should be very brief. 0.97. What is the ratio of the CO2 emissions (% of total fuel combustion) of Latin America(developing only) in 1989 to that in 1991?
Your response must be concise. 1.09. What is the ratio of the CO2 emissions (% of total fuel combustion) of Egypt, Arab Rep. in 1989 to that in 1991?
Make the answer very short. 1.1. What is the ratio of the CO2 emissions (% of total fuel combustion) of Tunisia in 1989 to that in 1991?
Make the answer very short. 1.1. What is the ratio of the CO2 emissions (% of total fuel combustion) in Latin America(developing only) in 1989 to that in 1992?
Keep it short and to the point. 1.11. What is the ratio of the CO2 emissions (% of total fuel combustion) in Egypt, Arab Rep. in 1989 to that in 1992?
Your answer should be very brief. 1.07. What is the ratio of the CO2 emissions (% of total fuel combustion) of Tunisia in 1989 to that in 1992?
Provide a short and direct response. 1.05. What is the ratio of the CO2 emissions (% of total fuel combustion) of Latin America(developing only) in 1989 to that in 1993?
Offer a terse response. 1.13. What is the ratio of the CO2 emissions (% of total fuel combustion) in Egypt, Arab Rep. in 1989 to that in 1993?
Your answer should be compact. 1. What is the ratio of the CO2 emissions (% of total fuel combustion) in Tunisia in 1989 to that in 1993?
Your response must be concise. 1.1. What is the ratio of the CO2 emissions (% of total fuel combustion) of Latin America(developing only) in 1989 to that in 1994?
Ensure brevity in your answer.  1.14. What is the ratio of the CO2 emissions (% of total fuel combustion) in Egypt, Arab Rep. in 1989 to that in 1994?
Offer a terse response. 1.25. What is the ratio of the CO2 emissions (% of total fuel combustion) in Tunisia in 1989 to that in 1994?
Your answer should be very brief. 1.18. What is the ratio of the CO2 emissions (% of total fuel combustion) in Latin America(developing only) in 1990 to that in 1991?
Give a very brief answer. 1.03. What is the ratio of the CO2 emissions (% of total fuel combustion) in Egypt, Arab Rep. in 1990 to that in 1991?
Provide a short and direct response. 1.08. What is the ratio of the CO2 emissions (% of total fuel combustion) of Tunisia in 1990 to that in 1991?
Your answer should be compact. 1.13. What is the ratio of the CO2 emissions (% of total fuel combustion) in Latin America(developing only) in 1990 to that in 1992?
Keep it short and to the point. 1.06. What is the ratio of the CO2 emissions (% of total fuel combustion) in Egypt, Arab Rep. in 1990 to that in 1992?
Your answer should be compact. 1.05. What is the ratio of the CO2 emissions (% of total fuel combustion) in Tunisia in 1990 to that in 1992?
Keep it short and to the point. 1.08. What is the ratio of the CO2 emissions (% of total fuel combustion) of Latin America(developing only) in 1990 to that in 1993?
Provide a succinct answer. 1.07. What is the ratio of the CO2 emissions (% of total fuel combustion) of Egypt, Arab Rep. in 1990 to that in 1993?
Provide a succinct answer. 0.98. What is the ratio of the CO2 emissions (% of total fuel combustion) of Tunisia in 1990 to that in 1993?
Your response must be concise. 1.13. What is the ratio of the CO2 emissions (% of total fuel combustion) in Latin America(developing only) in 1990 to that in 1994?
Offer a very short reply. 1.08. What is the ratio of the CO2 emissions (% of total fuel combustion) in Egypt, Arab Rep. in 1990 to that in 1994?
Your response must be concise. 1.22. What is the ratio of the CO2 emissions (% of total fuel combustion) of Tunisia in 1990 to that in 1994?
Your answer should be compact. 1.22. What is the ratio of the CO2 emissions (% of total fuel combustion) of Latin America(developing only) in 1991 to that in 1992?
Your response must be concise. 1.02. What is the ratio of the CO2 emissions (% of total fuel combustion) of Tunisia in 1991 to that in 1992?
Make the answer very short. 0.96. What is the ratio of the CO2 emissions (% of total fuel combustion) in Latin America(developing only) in 1991 to that in 1993?
Your response must be concise. 1.04. What is the ratio of the CO2 emissions (% of total fuel combustion) of Egypt, Arab Rep. in 1991 to that in 1993?
Provide a short and direct response. 0.91. What is the ratio of the CO2 emissions (% of total fuel combustion) in Latin America(developing only) in 1991 to that in 1994?
Keep it short and to the point. 1.04. What is the ratio of the CO2 emissions (% of total fuel combustion) of Egypt, Arab Rep. in 1991 to that in 1994?
Offer a very short reply. 1.13. What is the ratio of the CO2 emissions (% of total fuel combustion) of Tunisia in 1991 to that in 1994?
Keep it short and to the point. 1.08. What is the ratio of the CO2 emissions (% of total fuel combustion) in Latin America(developing only) in 1992 to that in 1993?
Provide a succinct answer. 1.01. What is the ratio of the CO2 emissions (% of total fuel combustion) in Egypt, Arab Rep. in 1992 to that in 1993?
Keep it short and to the point. 0.94. What is the ratio of the CO2 emissions (% of total fuel combustion) in Tunisia in 1992 to that in 1993?
Offer a terse response. 1.05. What is the ratio of the CO2 emissions (% of total fuel combustion) of Latin America(developing only) in 1992 to that in 1994?
Keep it short and to the point. 1.02. What is the ratio of the CO2 emissions (% of total fuel combustion) of Egypt, Arab Rep. in 1992 to that in 1994?
Provide a succinct answer. 1.17. What is the ratio of the CO2 emissions (% of total fuel combustion) of Tunisia in 1992 to that in 1994?
Give a very brief answer. 1.12. What is the ratio of the CO2 emissions (% of total fuel combustion) in Latin America(developing only) in 1993 to that in 1994?
Your answer should be very brief. 1.01. What is the ratio of the CO2 emissions (% of total fuel combustion) in Egypt, Arab Rep. in 1993 to that in 1994?
Provide a succinct answer. 1.24. What is the ratio of the CO2 emissions (% of total fuel combustion) in Tunisia in 1993 to that in 1994?
Your answer should be very brief. 1.08. What is the difference between the highest and the second highest CO2 emissions (% of total fuel combustion) in Latin America(developing only)?
Your response must be concise. 0.62. What is the difference between the highest and the second highest CO2 emissions (% of total fuel combustion) of Egypt, Arab Rep.?
Provide a short and direct response. 0.09. What is the difference between the highest and the second highest CO2 emissions (% of total fuel combustion) in Tunisia?
Your answer should be compact. 0.72. What is the difference between the highest and the lowest CO2 emissions (% of total fuel combustion) in Latin America(developing only)?
Make the answer very short. 4.03. What is the difference between the highest and the lowest CO2 emissions (% of total fuel combustion) of Egypt, Arab Rep.?
Ensure brevity in your answer.  7.4. What is the difference between the highest and the lowest CO2 emissions (% of total fuel combustion) of Tunisia?
Your response must be concise. 5.99. 